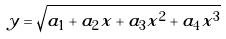Convert formula to latex. <formula><loc_0><loc_0><loc_500><loc_500>y = \sqrt { a _ { 1 } + a _ { 2 } x + a _ { 3 } x ^ { 2 } + a _ { 4 } x ^ { 3 } }</formula> 